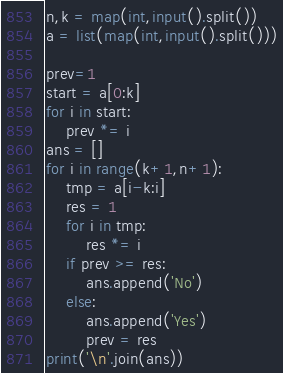<code> <loc_0><loc_0><loc_500><loc_500><_Python_>n,k = map(int,input().split())
a = list(map(int,input().split()))

prev=1
start = a[0:k]
for i in start:
    prev *= i
ans = []
for i in range(k+1,n+1):
    tmp = a[i-k:i]
    res = 1
    for i in tmp:
        res *= i
    if prev >= res:
        ans.append('No')
    else:
        ans.append('Yes')
        prev = res
print('\n'.join(ans))</code> 